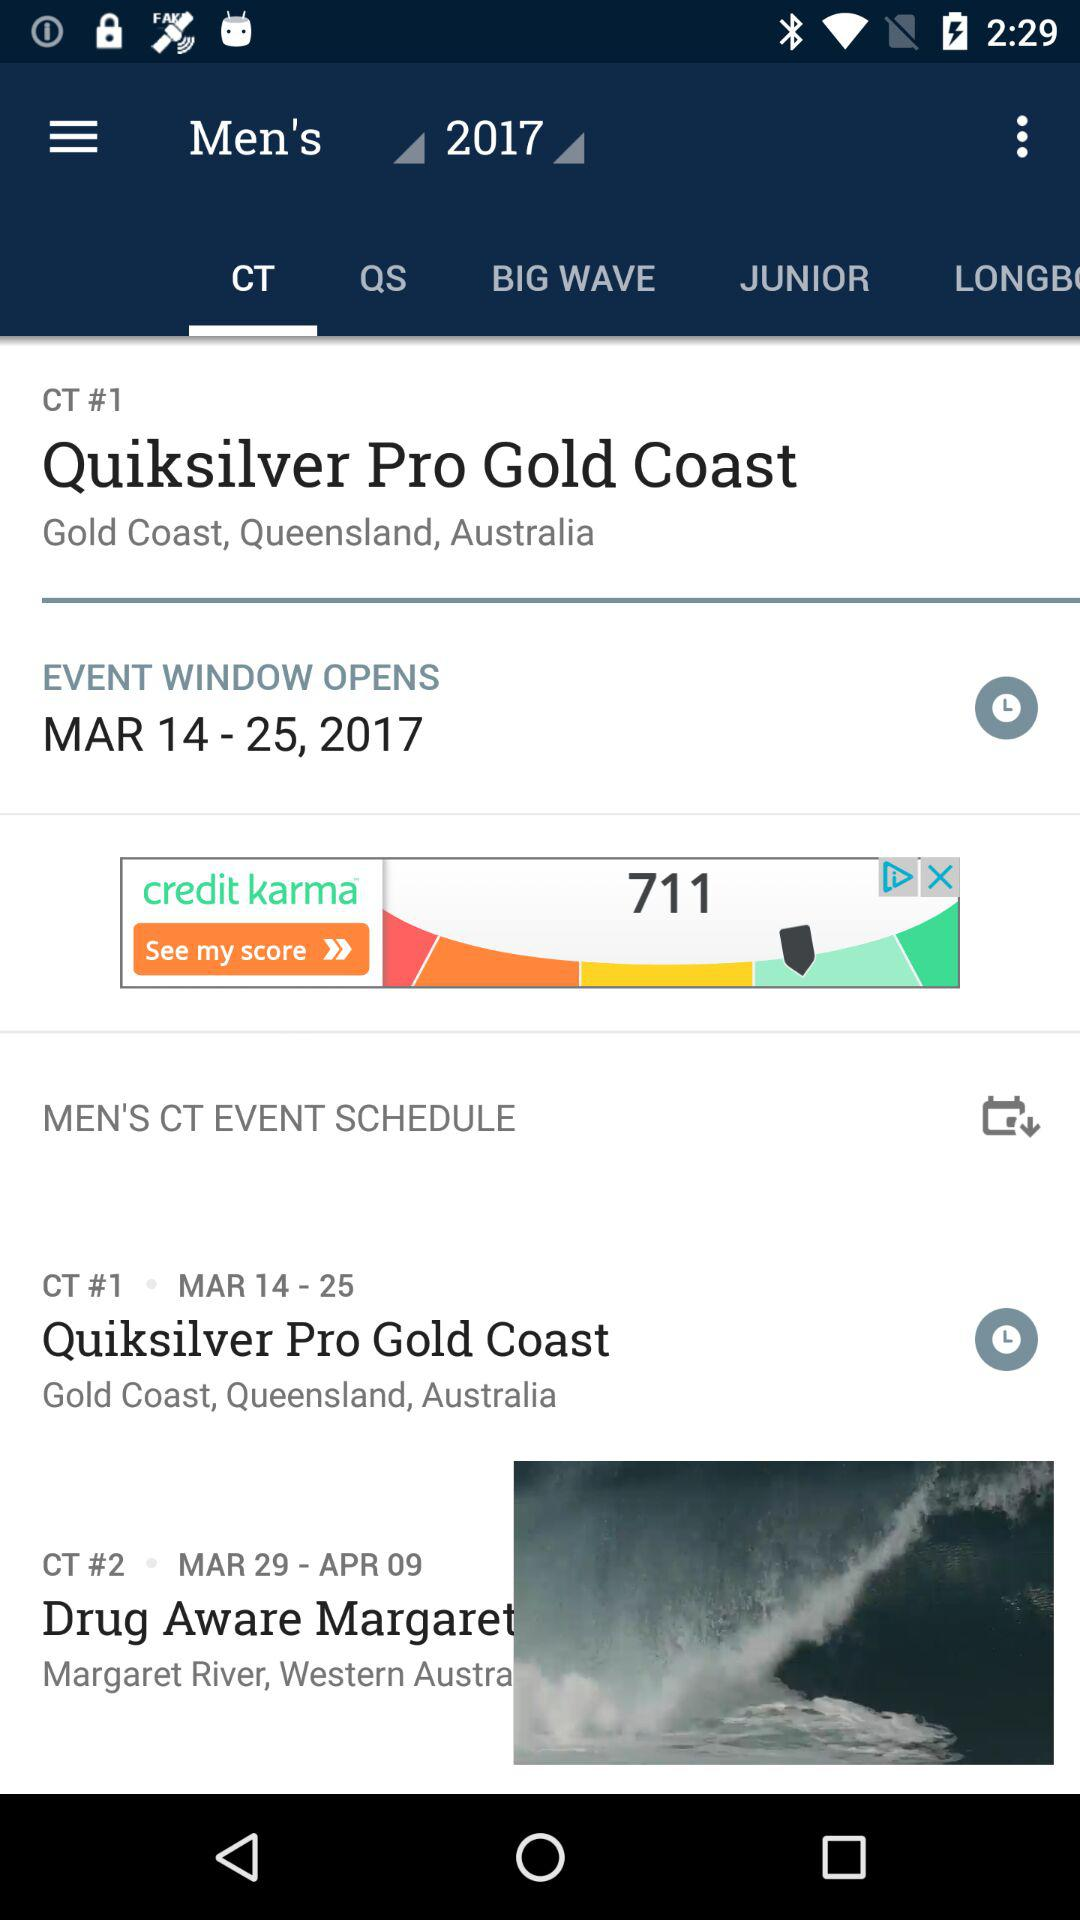Which year is selected? The selected year is 2017. 